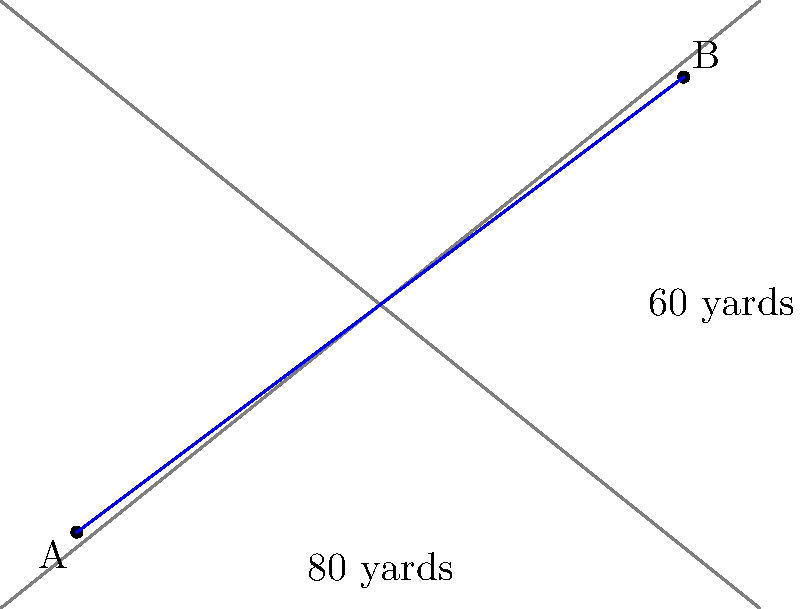On a disc golf course map, basket A is located at the origin (0,0) and basket B is at coordinates (80,60), where each unit represents 1 yard. What is the straight-line distance between these two baskets? To find the straight-line distance between two points, we can use the distance formula, which is derived from the Pythagorean theorem:

$d = \sqrt{(x_2-x_1)^2 + (y_2-y_1)^2}$

Where $(x_1,y_1)$ are the coordinates of point A and $(x_2,y_2)$ are the coordinates of point B.

Given:
- Point A: (0,0)
- Point B: (80,60)

Let's plug these values into the formula:

$d = \sqrt{(80-0)^2 + (60-0)^2}$

Simplify:
$d = \sqrt{80^2 + 60^2}$

Calculate the squares:
$d = \sqrt{6400 + 3600}$

Add under the square root:
$d = \sqrt{10000}$

Simplify:
$d = 100$

Therefore, the straight-line distance between the two baskets is 100 yards.
Answer: 100 yards 